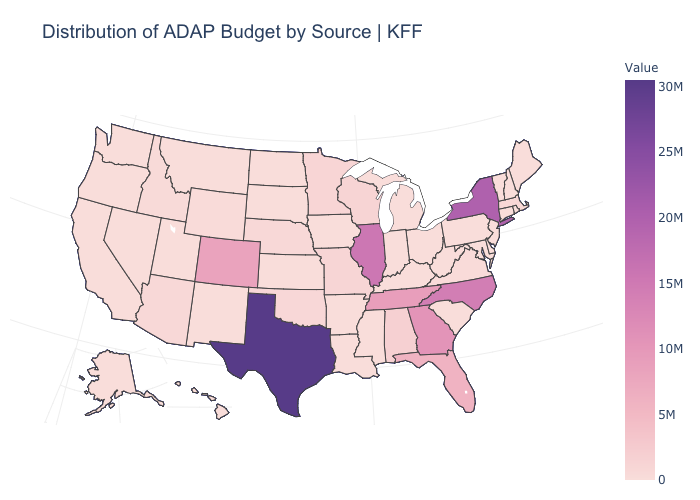Does South Dakota have the highest value in the USA?
Concise answer only. No. Among the states that border Indiana , does Michigan have the highest value?
Keep it brief. No. 